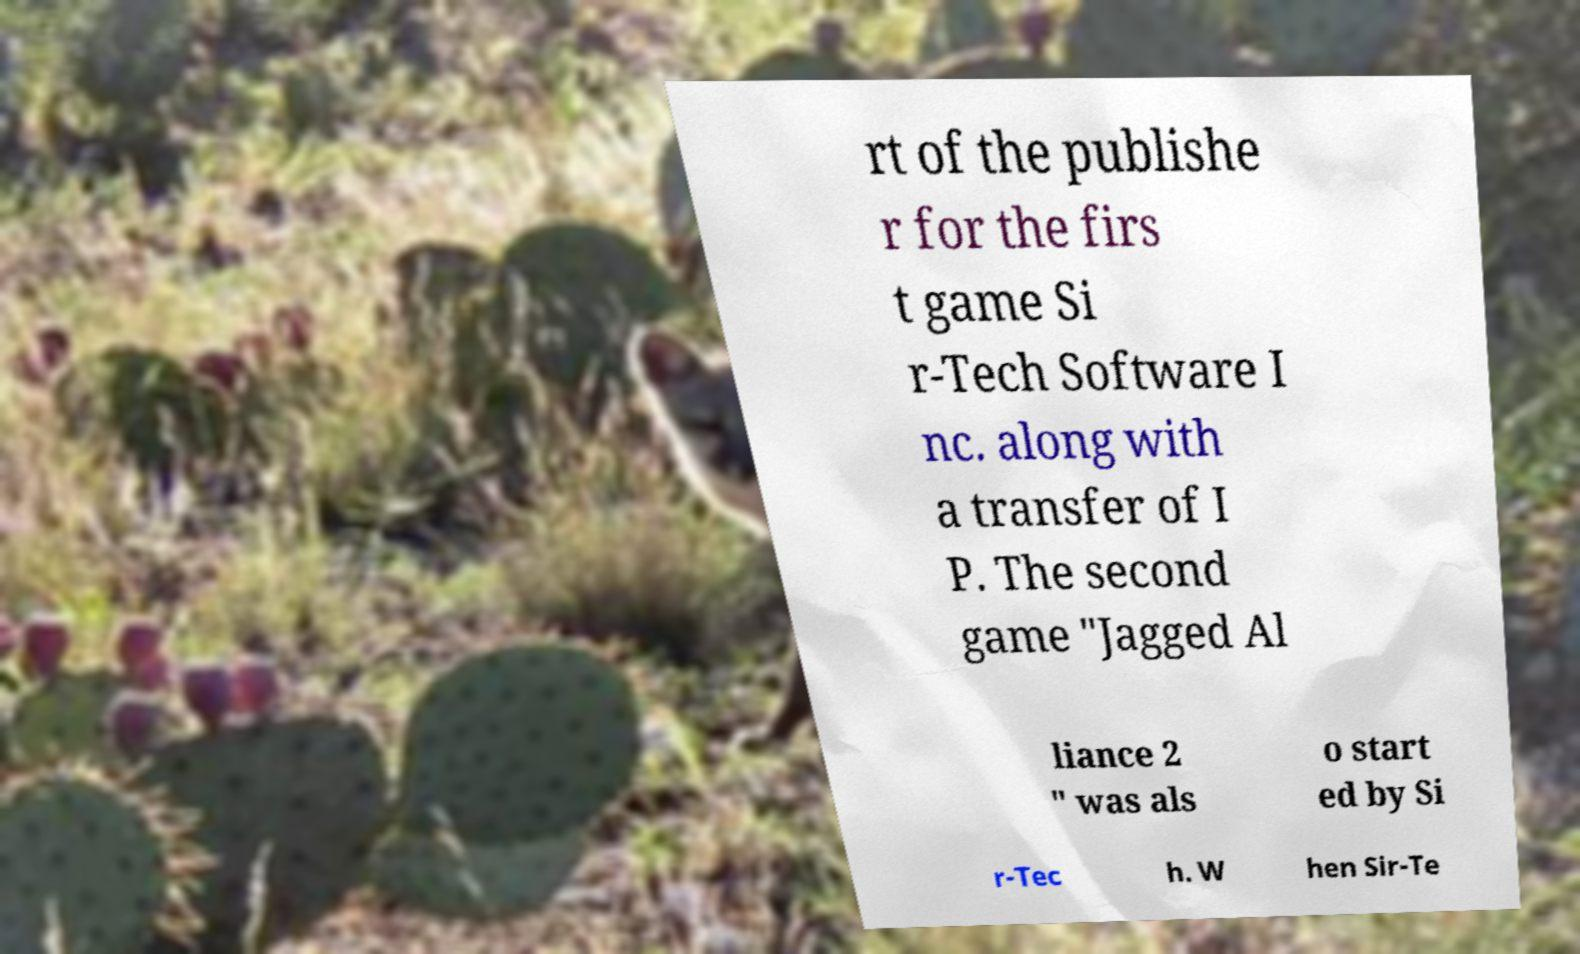There's text embedded in this image that I need extracted. Can you transcribe it verbatim? rt of the publishe r for the firs t game Si r-Tech Software I nc. along with a transfer of I P. The second game "Jagged Al liance 2 " was als o start ed by Si r-Tec h. W hen Sir-Te 